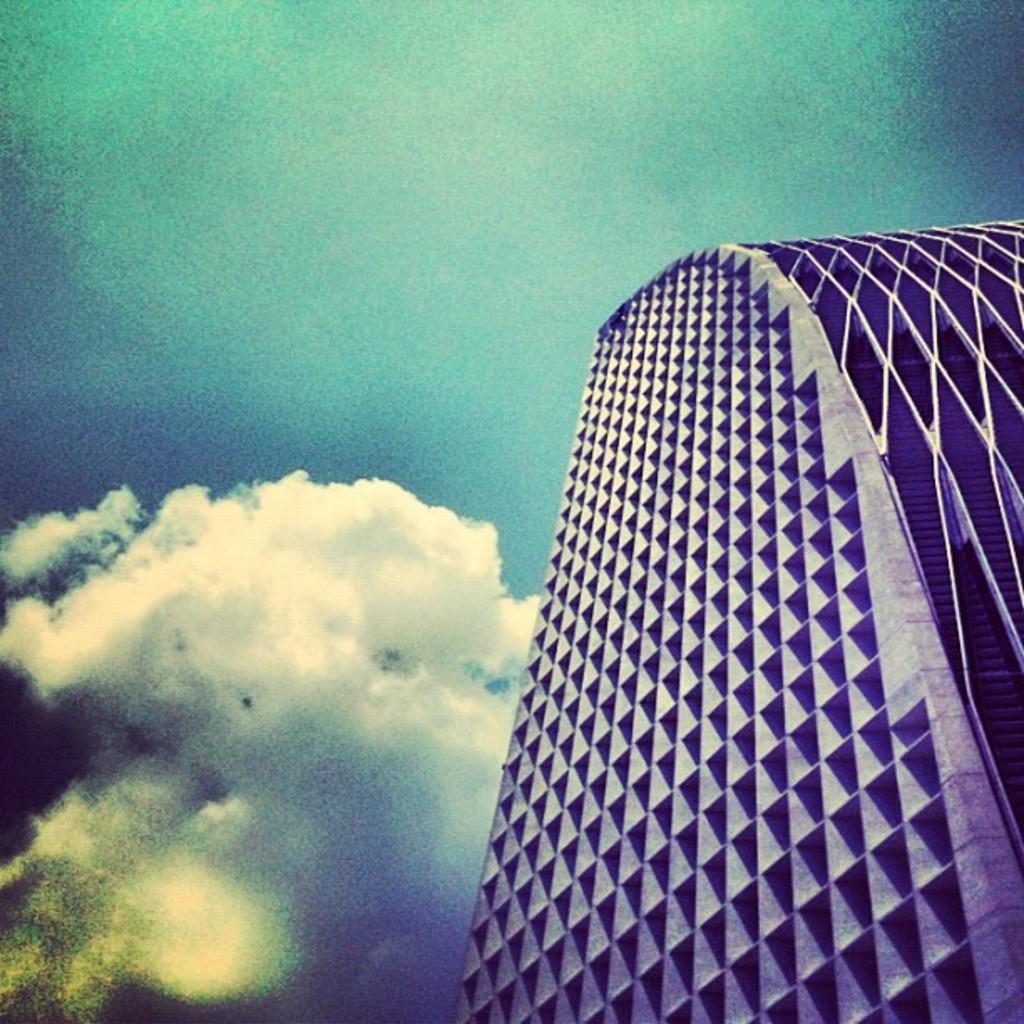In one or two sentences, can you explain what this image depicts? In the foreground of this image, there is a skyscraper on the right. On the top, there is the sky and the cloud. 